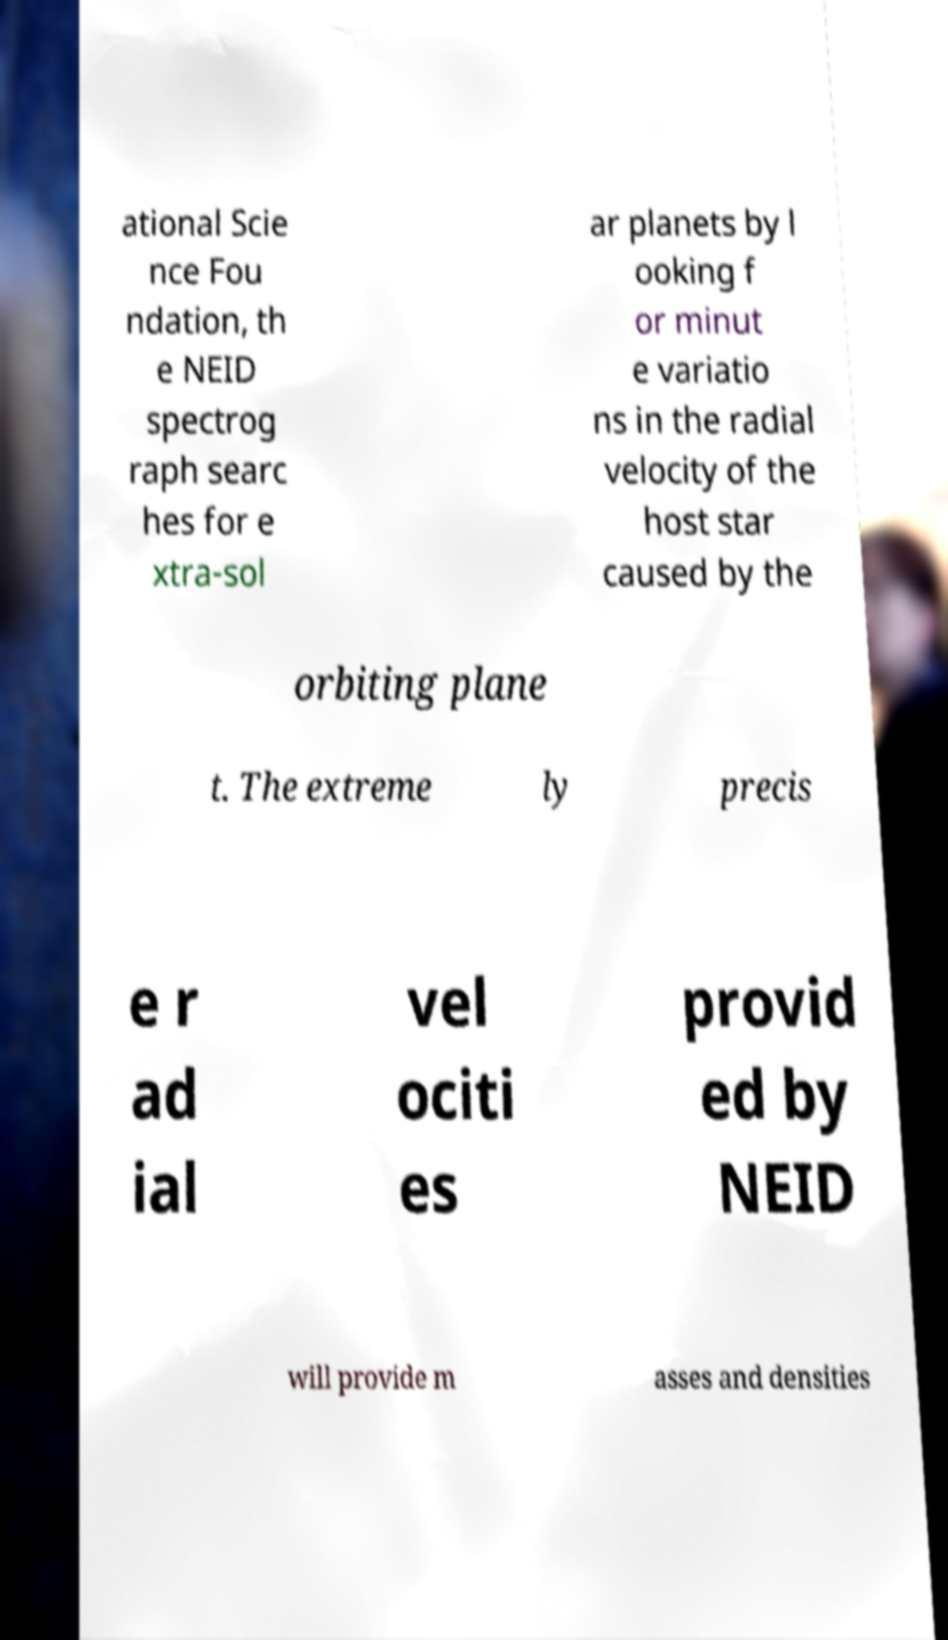Please identify and transcribe the text found in this image. ational Scie nce Fou ndation, th e NEID spectrog raph searc hes for e xtra-sol ar planets by l ooking f or minut e variatio ns in the radial velocity of the host star caused by the orbiting plane t. The extreme ly precis e r ad ial vel ociti es provid ed by NEID will provide m asses and densities 